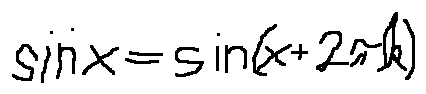Convert formula to latex. <formula><loc_0><loc_0><loc_500><loc_500>\sin x = \sin ( x + 2 \pi k )</formula> 